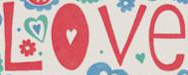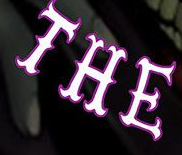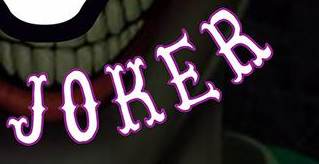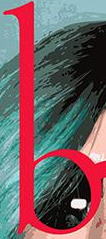What words can you see in these images in sequence, separated by a semicolon? Love; THE; JOKER; b 